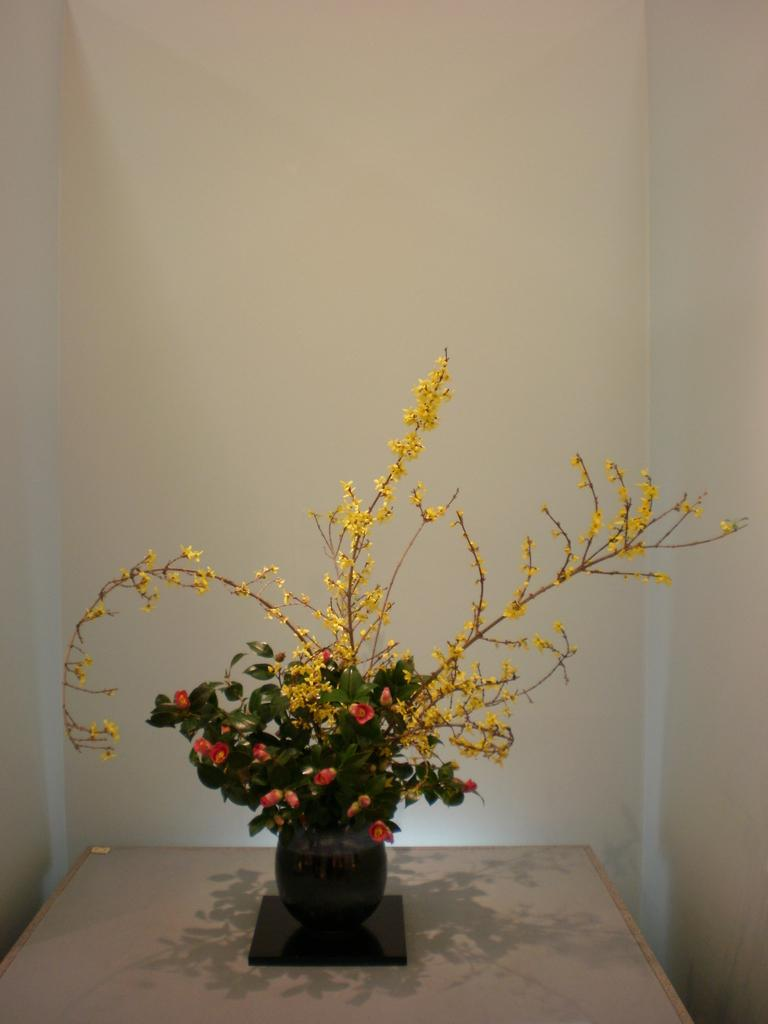What object is present in the image that contains flowers? There is a flower pot in the image that contains flowers. Where is the flower pot located? The flower pot is on top of a table. Are there any jellyfish visible in the image? No, there are no jellyfish present in the image. 